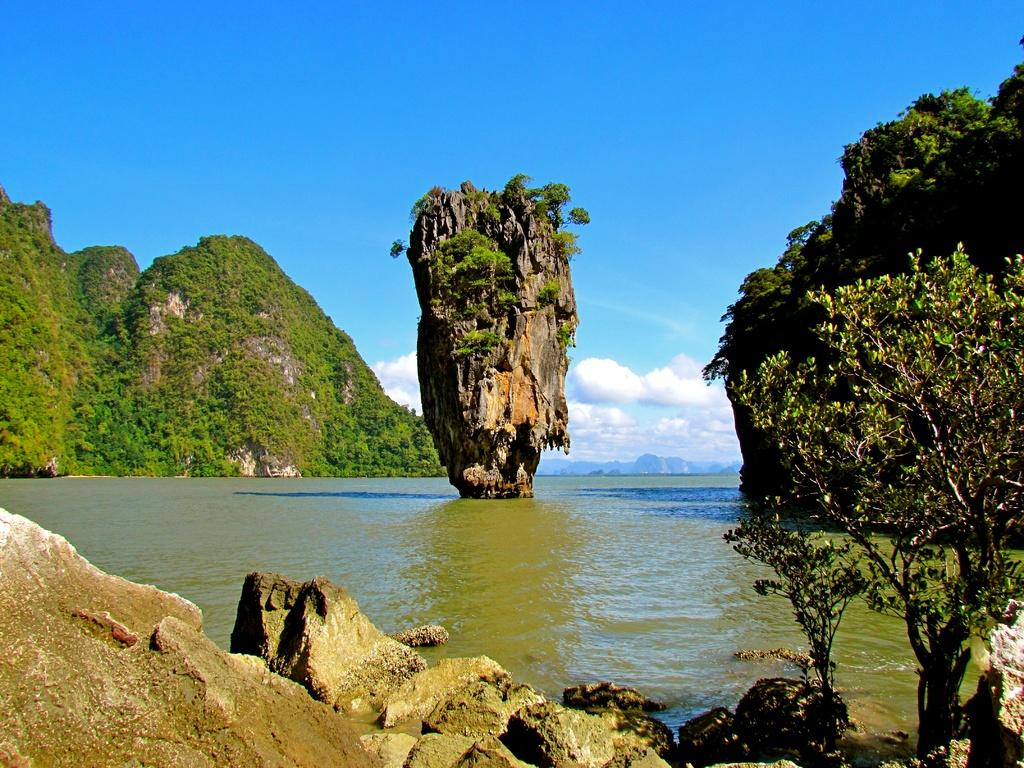What type of natural elements can be seen in the image? There are rocks, trees, and water visible in the image. What is located at the bottom of the image? There is water visible at the bottom of the image. What can be seen in the background of the image? There are hills and the sky visible in the background of the image. How many stems can be seen growing from the rocks in the image? There are no stems growing from the rocks in the image. What type of balance is depicted in the image? The image does not depict any specific balance; it is a landscape scene featuring rocks, trees, water, hills, and the sky. 